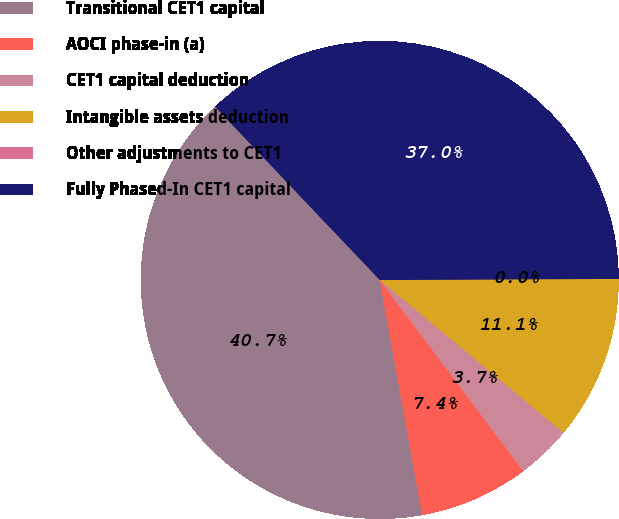Convert chart to OTSL. <chart><loc_0><loc_0><loc_500><loc_500><pie_chart><fcel>Transitional CET1 capital<fcel>AOCI phase-in (a)<fcel>CET1 capital deduction<fcel>Intangible assets deduction<fcel>Other adjustments to CET1<fcel>Fully Phased-In CET1 capital<nl><fcel>40.74%<fcel>7.41%<fcel>3.71%<fcel>11.11%<fcel>0.0%<fcel>37.03%<nl></chart> 